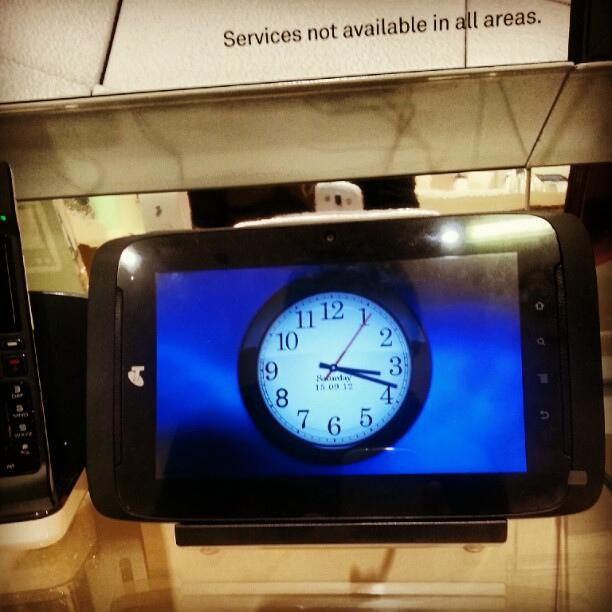What numbered day of the week is it?

Choices:
A) two
B) three
C) five
D) seven seven 